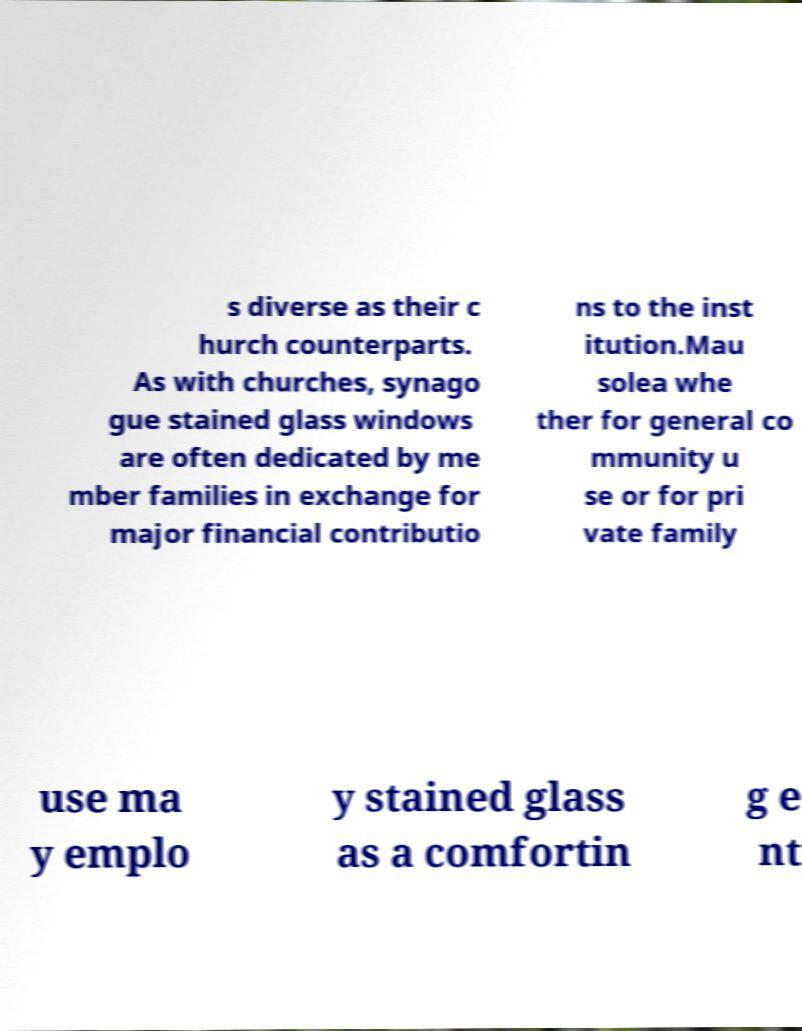Can you read and provide the text displayed in the image?This photo seems to have some interesting text. Can you extract and type it out for me? s diverse as their c hurch counterparts. As with churches, synago gue stained glass windows are often dedicated by me mber families in exchange for major financial contributio ns to the inst itution.Mau solea whe ther for general co mmunity u se or for pri vate family use ma y emplo y stained glass as a comfortin g e nt 